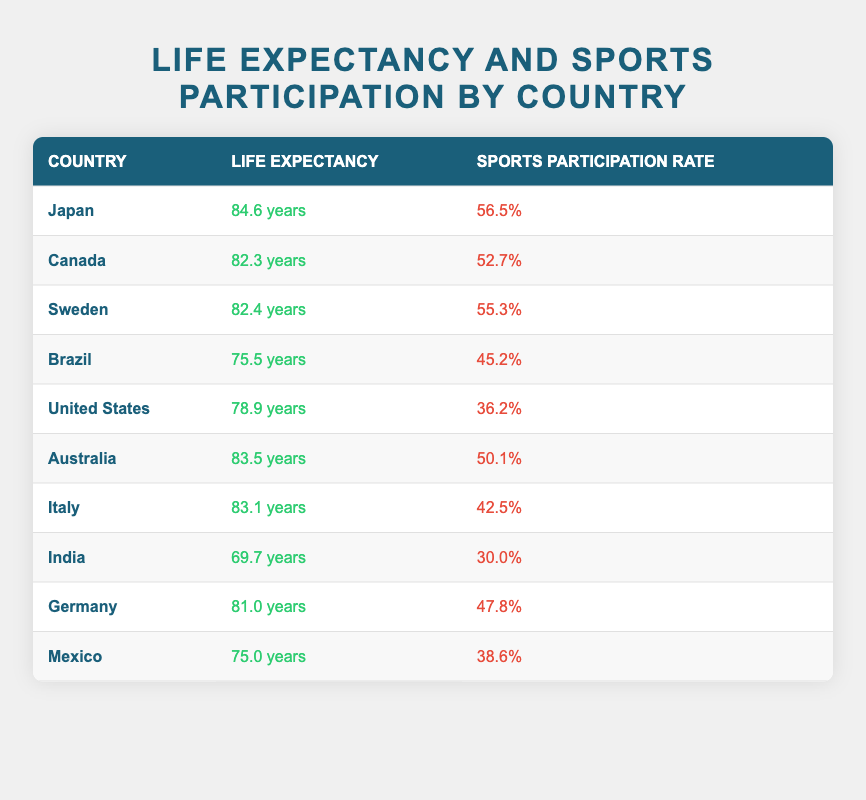What is the life expectancy of Japan? Referring to the table, Japan has a recorded life expectancy of 84.6 years.
Answer: 84.6 years Which country has the highest sports participation rate? Reviewing the table, Japan has the highest sports participation rate at 56.5%.
Answer: Japan Is the life expectancy of Australia greater than that of the United States? From the table, Australia has a life expectancy of 83.5 years, while the United States has a life expectancy of 78.9 years. Therefore, Australia’s life expectancy is greater.
Answer: Yes What is the average life expectancy of the top three countries by life expectancy? The top three countries are Japan (84.6), Canada (82.3), and Sweden (82.4). The sum is 84.6 + 82.3 + 82.4 = 249.3, and the average is 249.3 / 3 = 83.1.
Answer: 83.1 What is the difference in sports participation rate between Brazil and India? Brazil has a sports participation rate of 45.2% and India has 30.0%. Calculating the difference: 45.2 - 30.0 = 15.2.
Answer: 15.2 Is it true that Germany has a higher life expectancy than Italy? Germany has a life expectancy of 81.0 years while Italy has 83.1 years, which means Germany does not have a higher life expectancy than Italy.
Answer: No Which country has the lowest sports participation rate, and what is that rate? The country with the lowest sports participation rate is India with a rate of 30.0%.
Answer: India, 30.0% If we rank the countries based on life expectancy, how many countries have a life expectancy above 80 years? The countries above 80 years are Japan (84.6), Canada (82.3), Sweden (82.4), Australia (83.5), and Italy (83.1). The count is 5.
Answer: 5 What is the correlation between the sports participation rate and life expectancy in general based on the provided data? While the exact correlation coefficient is not calculated here, generally, higher sports participation rates correlate with higher life expectancy, as seen with Japan (highest participation and life expectancy) and India (lowest).
Answer: Higher correlation 